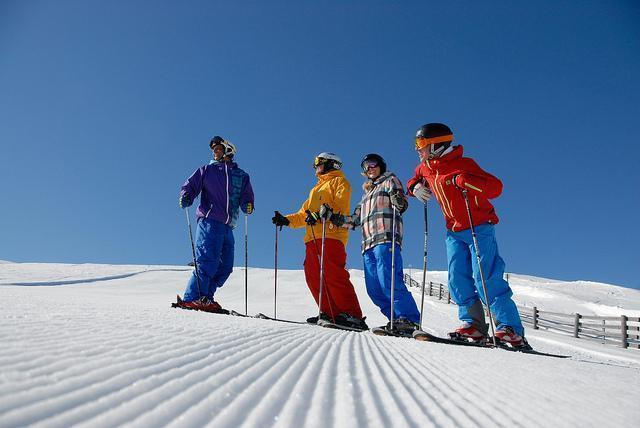How many people are in the scene?
Give a very brief answer. 4. How many people are wearing blue pants?
Give a very brief answer. 3. How many people are there?
Give a very brief answer. 4. How many elephants are there?
Give a very brief answer. 0. 